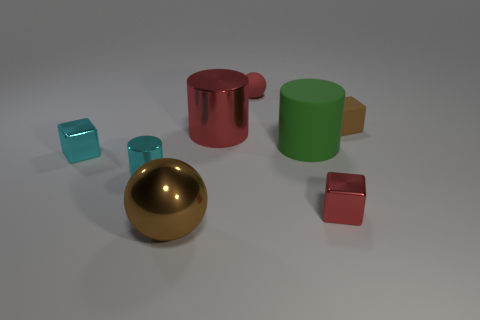Is the number of red blocks that are left of the brown shiny ball less than the number of cyan metallic cubes behind the red metal cube?
Ensure brevity in your answer.  Yes. How many large cylinders are on the right side of the rubber block?
Your response must be concise. 0. Is there a brown ball made of the same material as the small cyan cube?
Give a very brief answer. Yes. Are there more large brown spheres that are behind the small red matte object than big brown objects that are on the right side of the big shiny ball?
Provide a succinct answer. No. The cyan cylinder has what size?
Your response must be concise. Small. The matte thing right of the red metal block has what shape?
Offer a very short reply. Cube. Is the shape of the big green thing the same as the large red object?
Your response must be concise. Yes. Are there the same number of objects left of the big brown object and cyan metallic things?
Your answer should be very brief. Yes. What is the shape of the brown shiny thing?
Your response must be concise. Sphere. Is there any other thing of the same color as the large ball?
Offer a very short reply. Yes. 